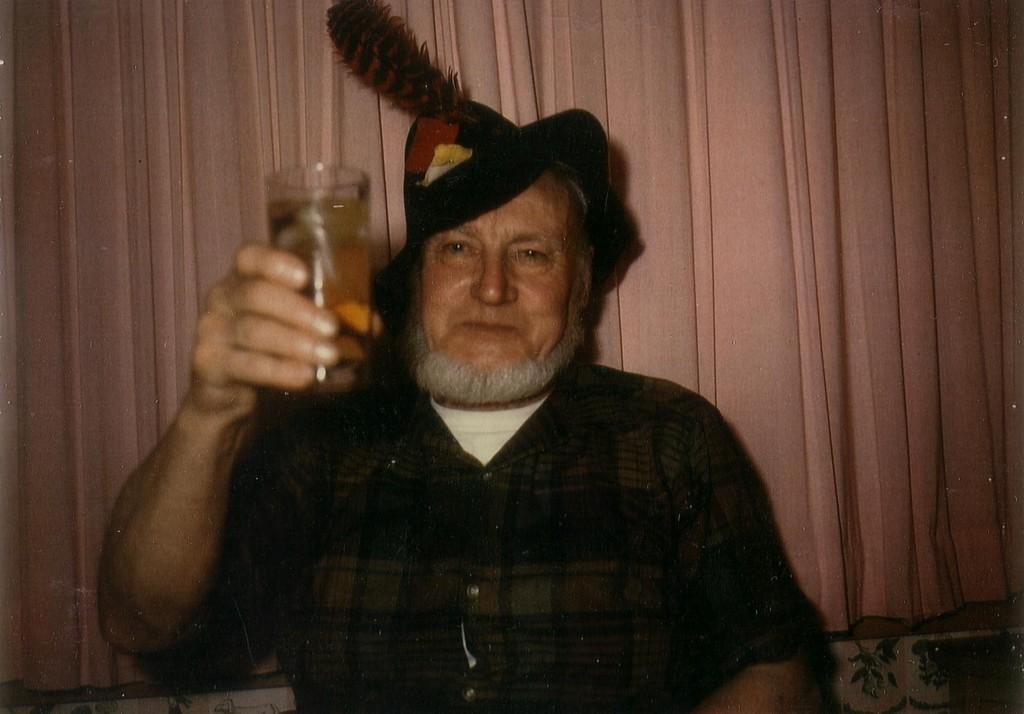What is the main subject of the image? There is a person in the image. What is the person wearing on their head? The person is wearing a cap. What object is the person holding in the image? The person is holding a glass. How many pizzas can be seen being kicked in the image? There are no pizzas or kicking actions present in the image. 